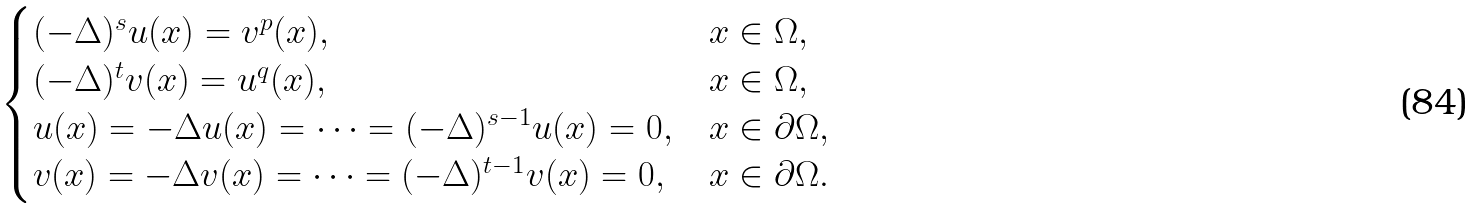Convert formula to latex. <formula><loc_0><loc_0><loc_500><loc_500>\begin{cases} ( - \Delta ) ^ { s } u ( x ) = v ^ { p } ( x ) , & x \in \Omega , \\ ( - \Delta ) ^ { t } v ( x ) = u ^ { q } ( x ) , & x \in \Omega , \\ u ( x ) = - \Delta u ( x ) = \cdots = ( - \Delta ) ^ { s - 1 } u ( x ) = 0 , & x \in \partial \Omega , \\ v ( x ) = - \Delta v ( x ) = \cdots = ( - \Delta ) ^ { t - 1 } v ( x ) = 0 , & x \in \partial \Omega . \end{cases}</formula> 